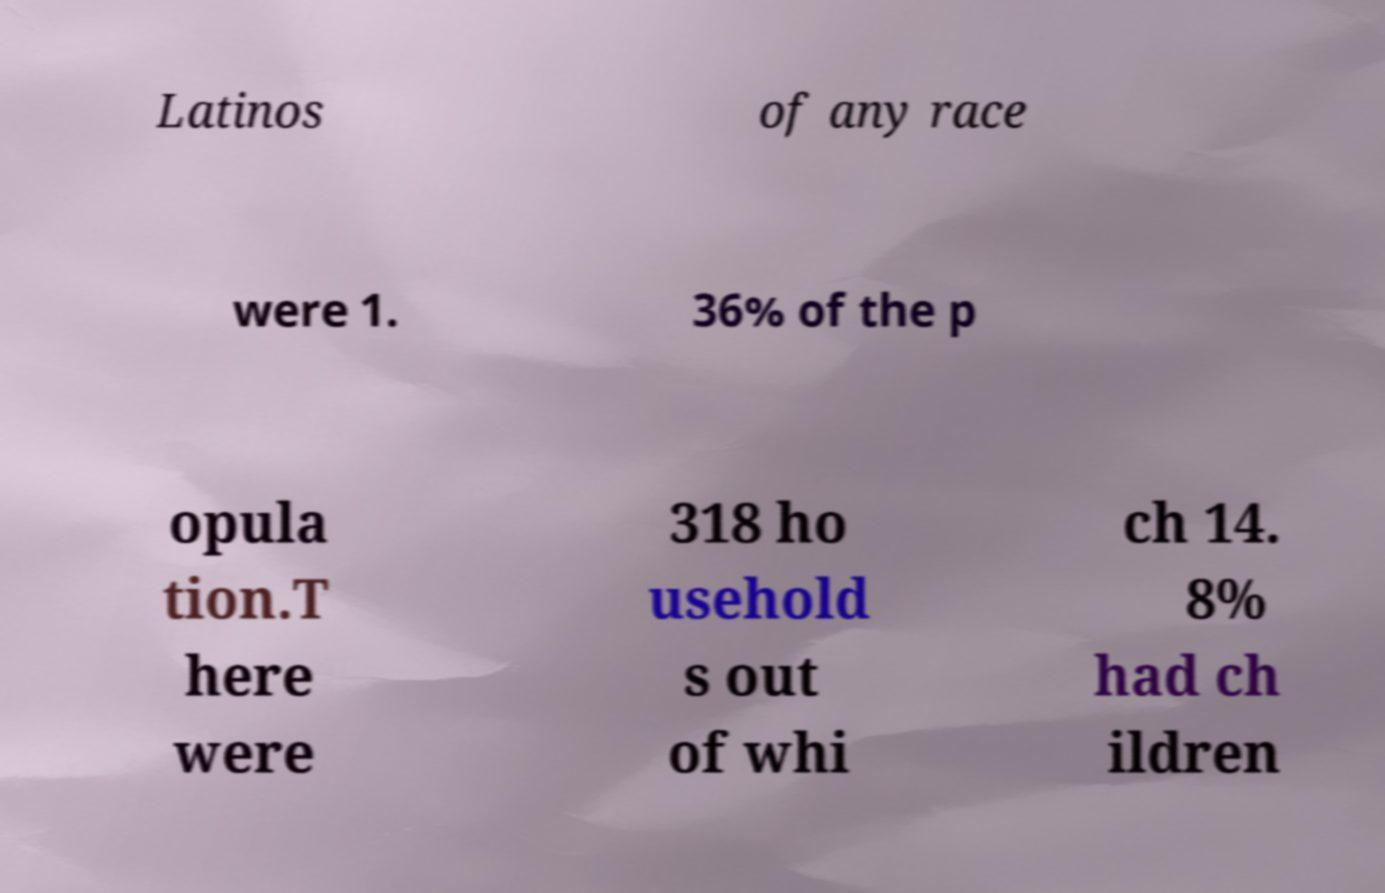What messages or text are displayed in this image? I need them in a readable, typed format. Latinos of any race were 1. 36% of the p opula tion.T here were 318 ho usehold s out of whi ch 14. 8% had ch ildren 